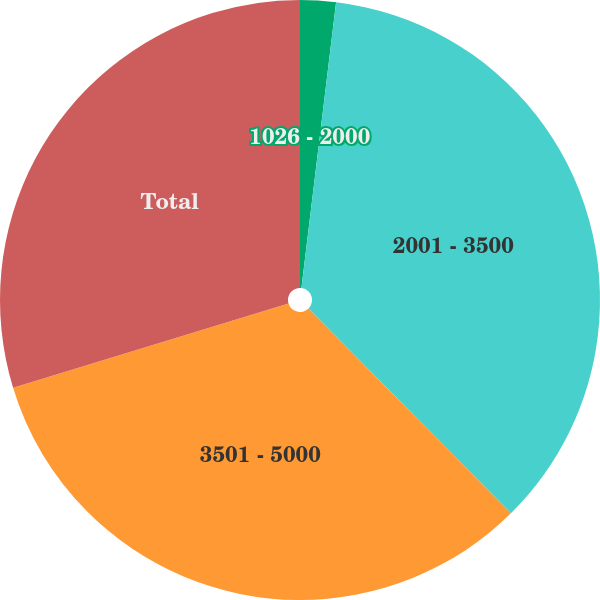Convert chart to OTSL. <chart><loc_0><loc_0><loc_500><loc_500><pie_chart><fcel>1026 - 2000<fcel>2001 - 3500<fcel>3501 - 5000<fcel>Total<nl><fcel>1.92%<fcel>35.67%<fcel>32.69%<fcel>29.72%<nl></chart> 